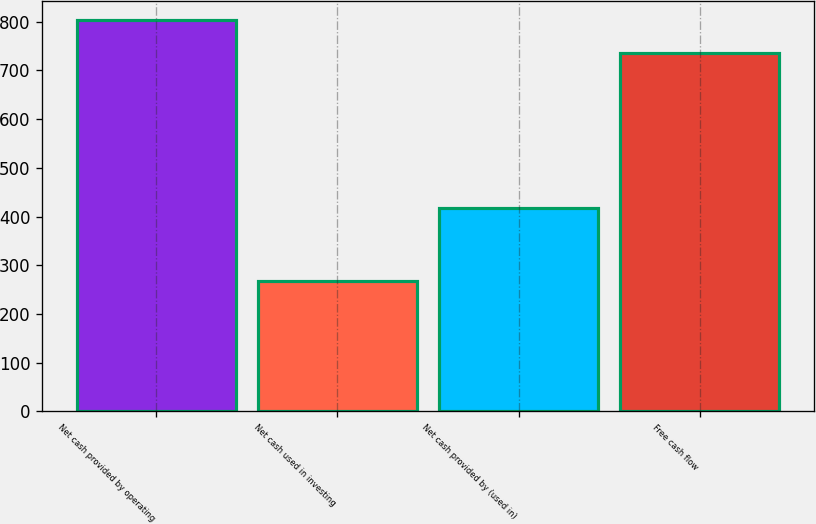<chart> <loc_0><loc_0><loc_500><loc_500><bar_chart><fcel>Net cash provided by operating<fcel>Net cash used in investing<fcel>Net cash provided by (used in)<fcel>Free cash flow<nl><fcel>803.3<fcel>267.6<fcel>417.7<fcel>735.6<nl></chart> 